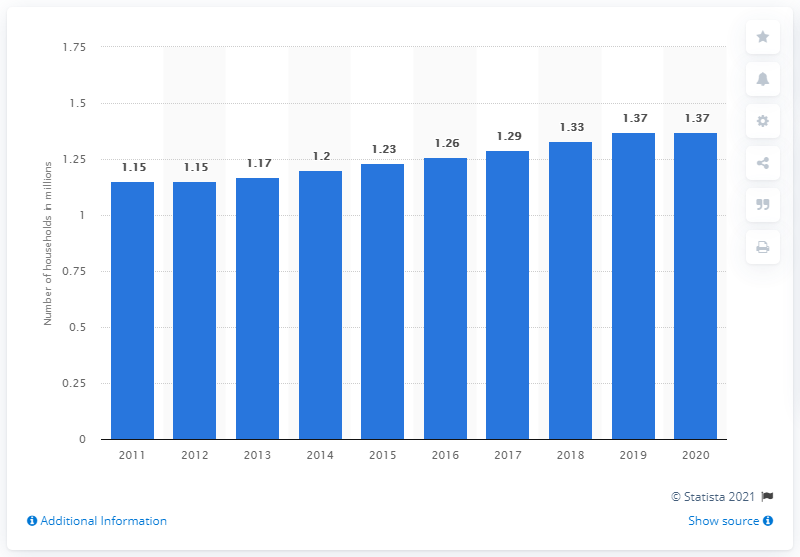Draw attention to some important aspects in this diagram. In 2020, there were approximately 1.37 households in Singapore. 